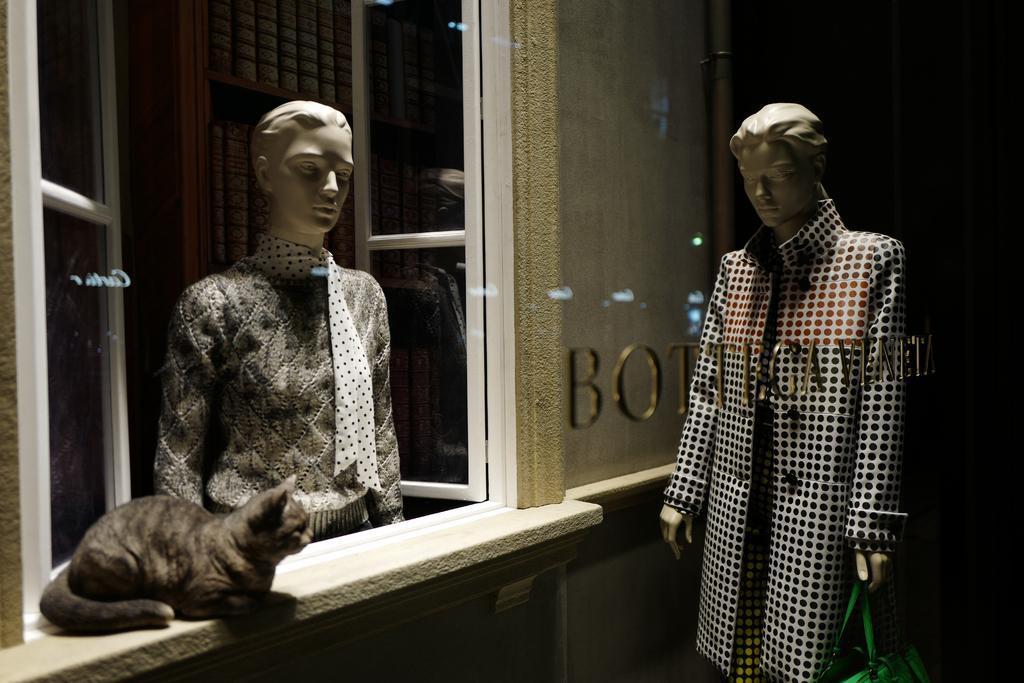Please provide a concise description of this image. In this image I see 2 mannequins and this mannequin is holding a green color bag and I see a cat on this white surface and I see the windows over here and I see the wall and I see a word written on this glass and it is dark in the background. 